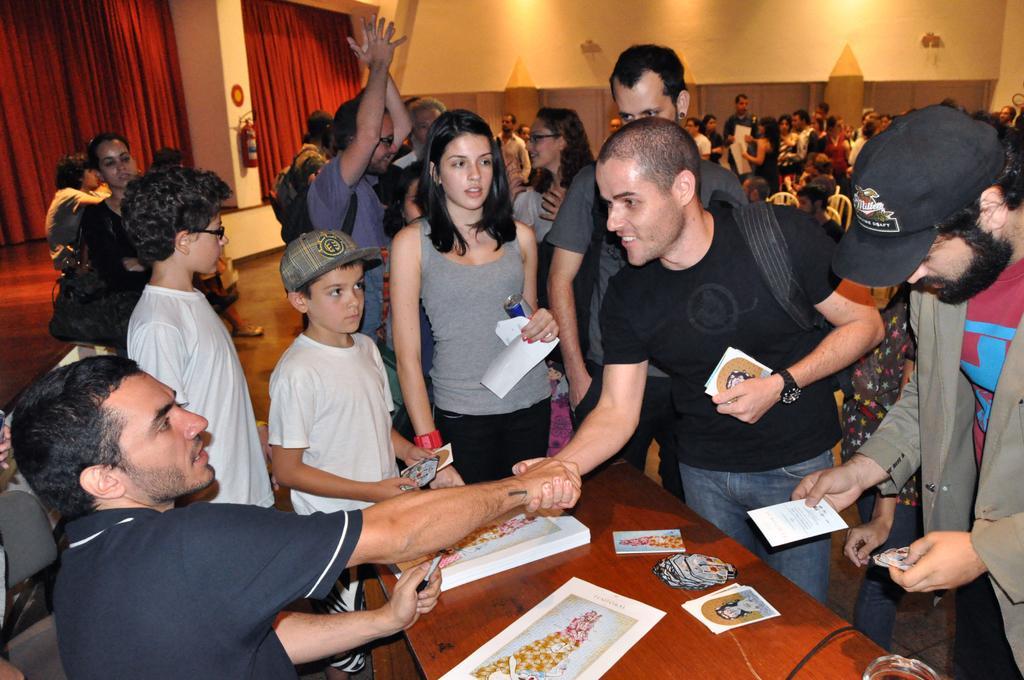How would you summarize this image in a sentence or two? In this image we can see some people sitting on the chairs and some are standing on the floor. In the background there are curtains, fire extinguishers, books, papers and some pictures on the table. 